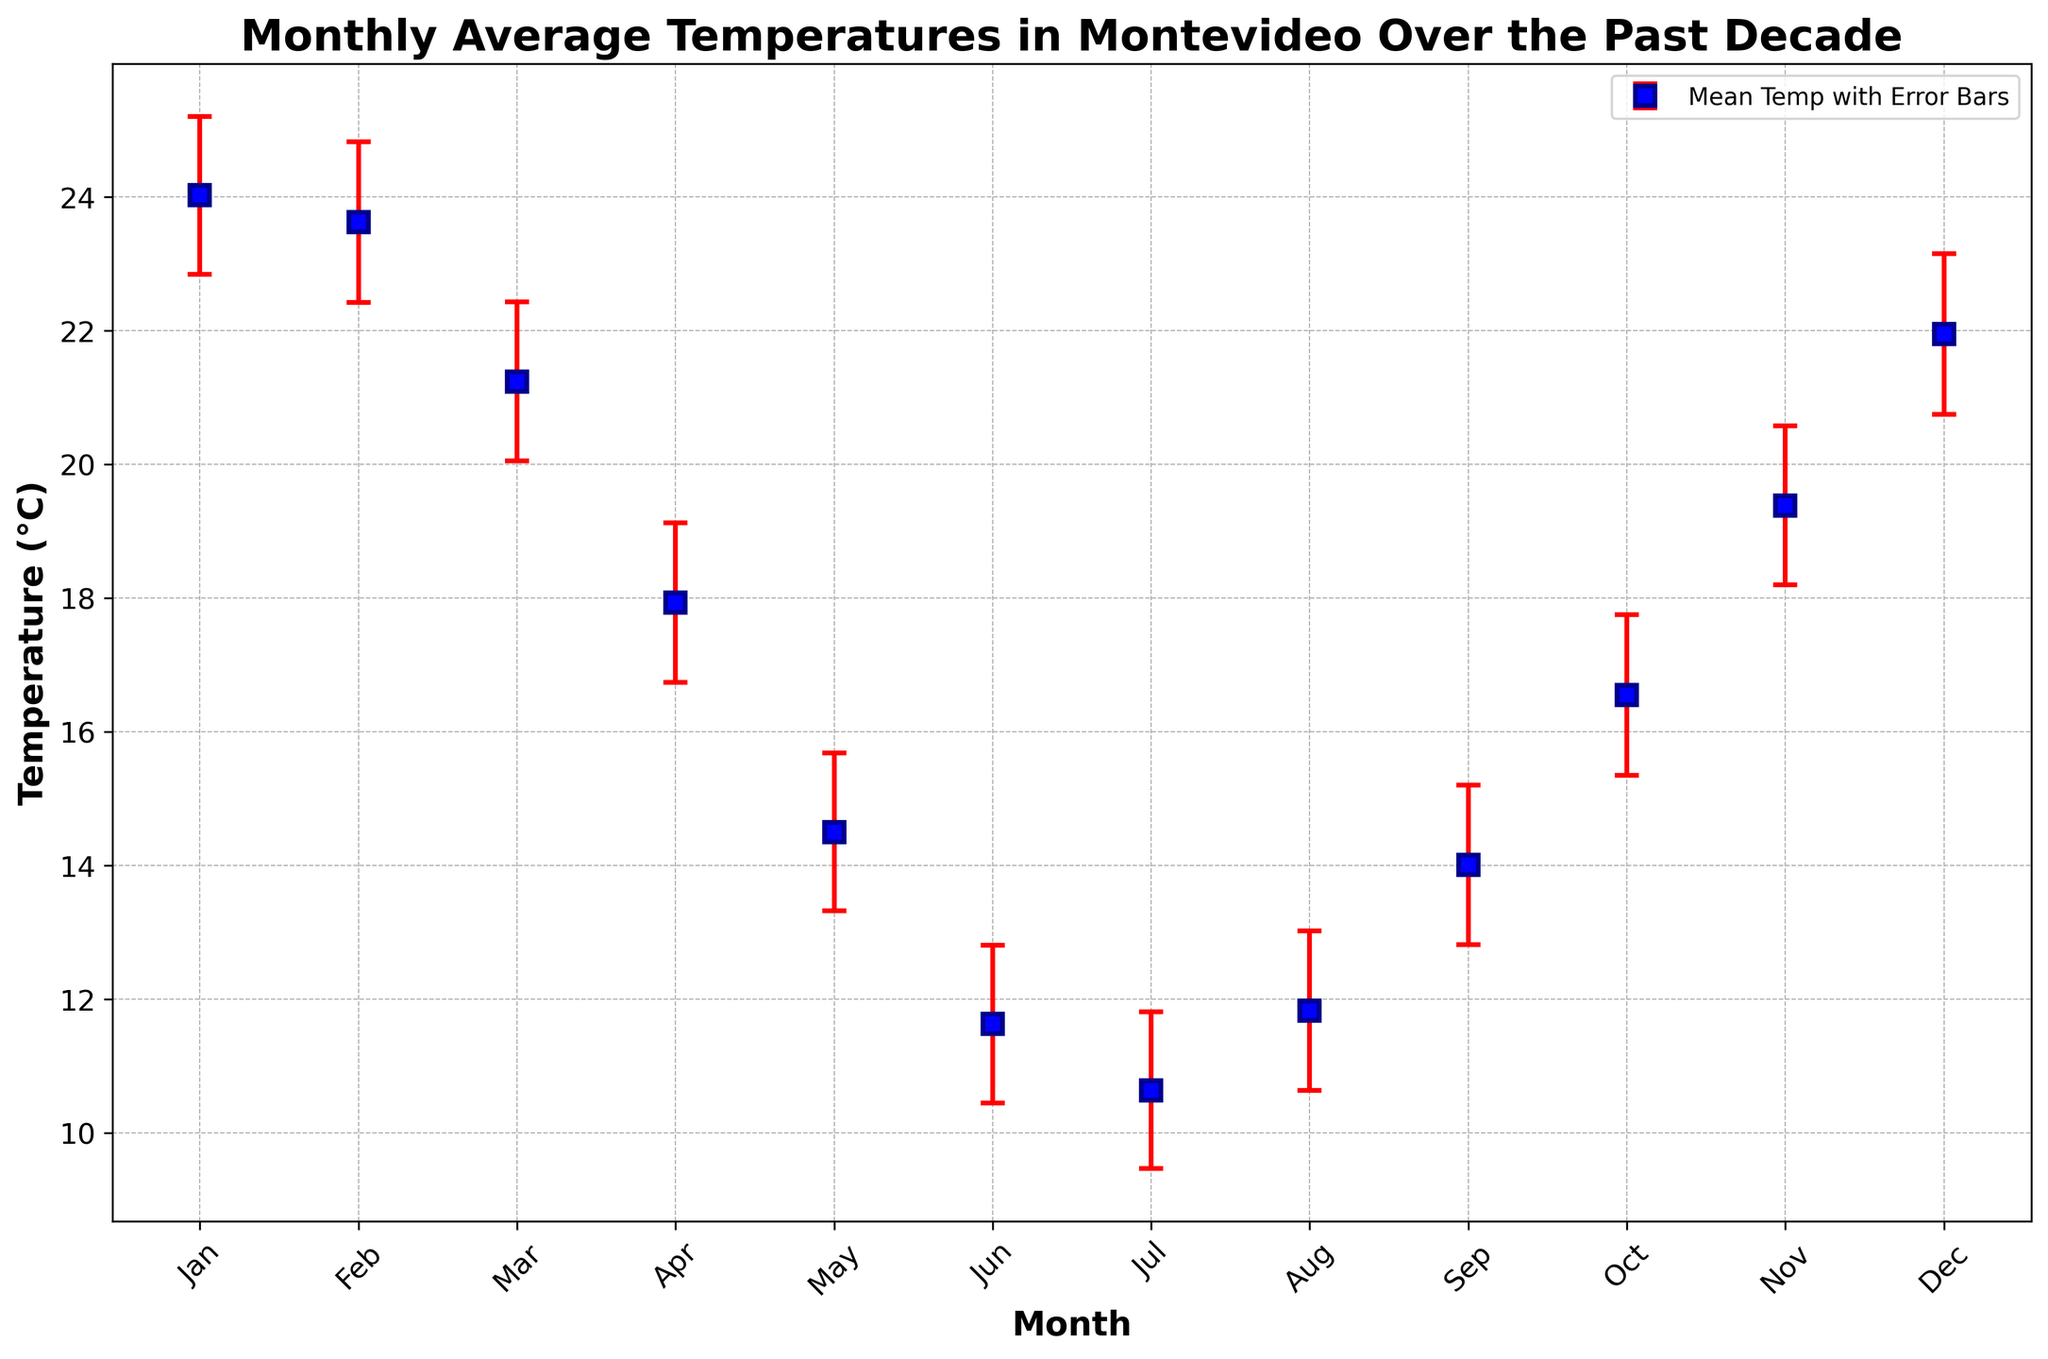Which month has the highest average temperature? The month with the highest average temperature can be identified by looking at the peak of the plot. January has the highest point on the graph.
Answer: January Which month has the lowest average temperature? To find the lowest average temperature, identify the point at the bottom of the plot. July shows the lowest point on the graph.
Answer: July What's the range of average temperatures in January over the past decade? The range is calculated by subtracting the lowest error bound from the highest error bound. For January, the lowest bound is 22.5°C and the highest is 25.5°C. So, 25.5 - 22.5 = 3.0°C
Answer: 3.0°C How does the average temperature in July compare to that in January? Comparing the points for January and July, January has a much higher average temperature than July. In January, the average temperature is around 24.1°C to 24.3°C, while in July, it is around 10.5°C to 10.7°C.
Answer: January > July Which month has the highest variability in temperature? Variability is shown by the length of the error bars. January has the longest error bars indicating the highest variability in temperature.
Answer: January What is the average temperature difference between December and January? The average temperature in January is around 24.1°C and in December, it is around 21.9°C. The difference is 24.1 - 21.9 = 2.2°C
Answer: 2.2°C How does the average temperature in April compare between the beginning and the end of the decade? To answer this, we look at the points corresponding to April from 2013 and 2023. Both points are plotted close together around 17.8-18.1°C, suggesting little change.
Answer: Similar What is the average temperature for the coldest and hottest months combined? The hottest month is January (average ≈ 24.1°C) and the coldest is July (average ≈ 10.6°C). Combined average is (24.1 + 10.6) / 2 = 17.35°C
Answer: 17.35°C Which month appears to be the most stable in terms of temperature? Stability is indicated by the shortest error bars. May has consistently short error bars indicating it is the most stable month.
Answer: May Which months have error bounds overlapping the 20°C mark? Examining the error bars, November and March overlap the 20°C mark at their upper limits.
Answer: November and March 